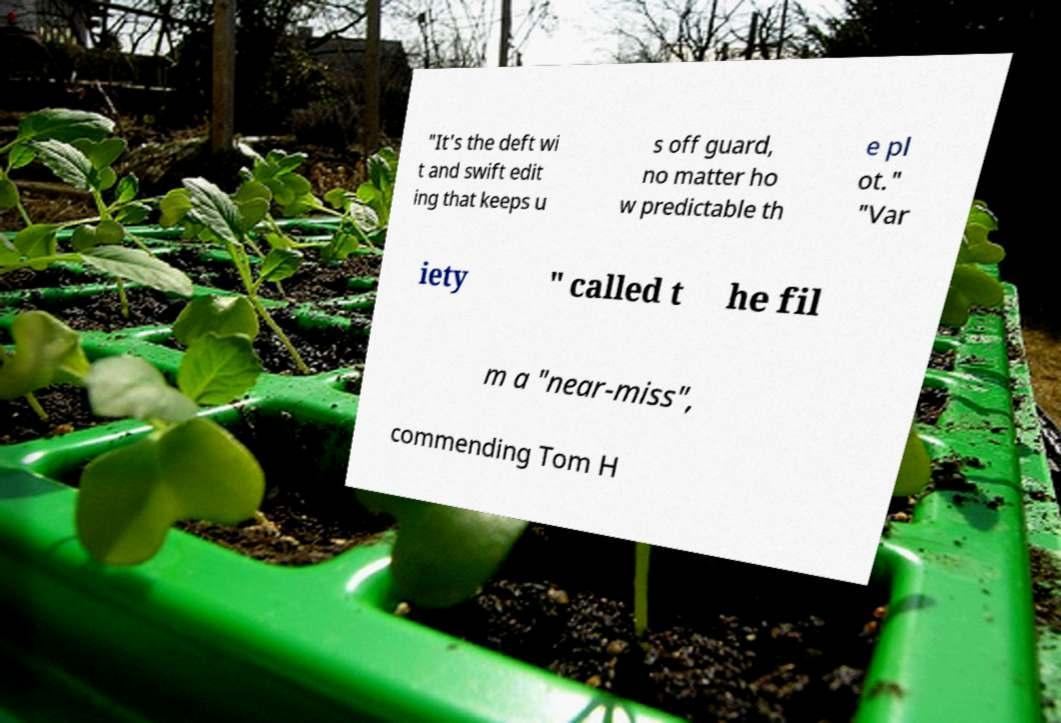Can you read and provide the text displayed in the image?This photo seems to have some interesting text. Can you extract and type it out for me? "It's the deft wi t and swift edit ing that keeps u s off guard, no matter ho w predictable th e pl ot." "Var iety " called t he fil m a "near-miss", commending Tom H 